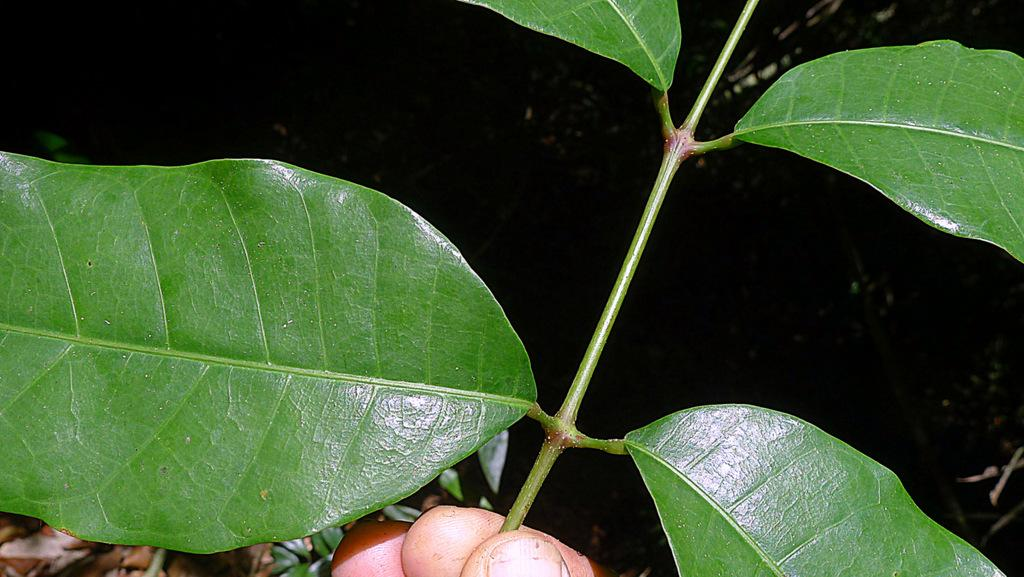What can be seen in the foreground of the image? There is a person's hand in the foreground of the image. What is the hand holding? The hand is holding a stem. What is attached to the stem? The stem has leaves. What is the color of the background in the image? The background of the image is dark. What type of thread can be seen being used for an activity in the image? There is no thread or activity involving thread present in the image. 